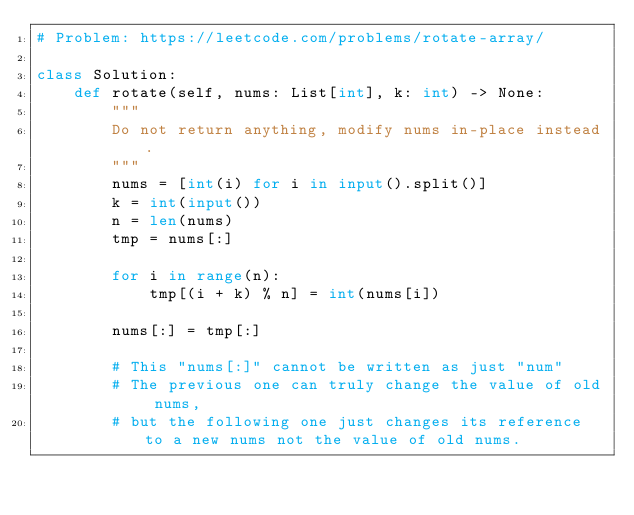Convert code to text. <code><loc_0><loc_0><loc_500><loc_500><_Python_># Problem: https://leetcode.com/problems/rotate-array/

class Solution:
    def rotate(self, nums: List[int], k: int) -> None:
        """
        Do not return anything, modify nums in-place instead.
        """
        nums = [int(i) for i in input().split()]
        k = int(input())
        n = len(nums)
        tmp = nums[:]

        for i in range(n):
            tmp[(i + k) % n] = int(nums[i])

        nums[:] = tmp[:]

        # This "nums[:]" cannot be written as just "num"
        # The previous one can truly change the value of old nums, 
        # but the following one just changes its reference to a new nums not the value of old nums.</code> 